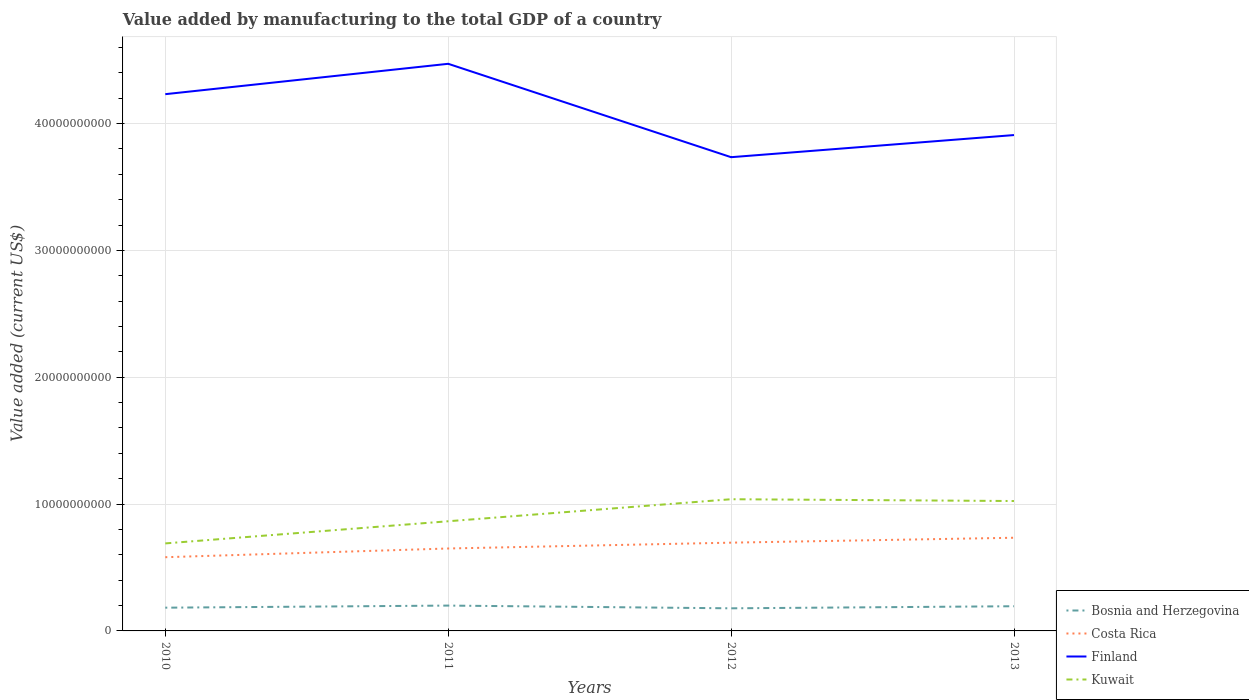How many different coloured lines are there?
Ensure brevity in your answer.  4. Across all years, what is the maximum value added by manufacturing to the total GDP in Kuwait?
Offer a terse response. 6.90e+09. In which year was the value added by manufacturing to the total GDP in Finland maximum?
Keep it short and to the point. 2012. What is the total value added by manufacturing to the total GDP in Kuwait in the graph?
Your answer should be very brief. -3.48e+09. What is the difference between the highest and the second highest value added by manufacturing to the total GDP in Kuwait?
Your response must be concise. 3.48e+09. How many lines are there?
Keep it short and to the point. 4. What is the difference between two consecutive major ticks on the Y-axis?
Your answer should be very brief. 1.00e+1. Does the graph contain any zero values?
Your response must be concise. No. Does the graph contain grids?
Make the answer very short. Yes. Where does the legend appear in the graph?
Provide a succinct answer. Bottom right. How are the legend labels stacked?
Your answer should be very brief. Vertical. What is the title of the graph?
Keep it short and to the point. Value added by manufacturing to the total GDP of a country. Does "Middle East & North Africa (developing only)" appear as one of the legend labels in the graph?
Offer a very short reply. No. What is the label or title of the Y-axis?
Make the answer very short. Value added (current US$). What is the Value added (current US$) of Bosnia and Herzegovina in 2010?
Give a very brief answer. 1.83e+09. What is the Value added (current US$) of Costa Rica in 2010?
Your answer should be very brief. 5.81e+09. What is the Value added (current US$) in Finland in 2010?
Provide a short and direct response. 4.23e+1. What is the Value added (current US$) of Kuwait in 2010?
Offer a terse response. 6.90e+09. What is the Value added (current US$) in Bosnia and Herzegovina in 2011?
Keep it short and to the point. 2.00e+09. What is the Value added (current US$) of Costa Rica in 2011?
Ensure brevity in your answer.  6.50e+09. What is the Value added (current US$) of Finland in 2011?
Make the answer very short. 4.47e+1. What is the Value added (current US$) of Kuwait in 2011?
Give a very brief answer. 8.65e+09. What is the Value added (current US$) in Bosnia and Herzegovina in 2012?
Offer a very short reply. 1.78e+09. What is the Value added (current US$) of Costa Rica in 2012?
Ensure brevity in your answer.  6.96e+09. What is the Value added (current US$) of Finland in 2012?
Provide a succinct answer. 3.73e+1. What is the Value added (current US$) in Kuwait in 2012?
Your answer should be very brief. 1.04e+1. What is the Value added (current US$) of Bosnia and Herzegovina in 2013?
Provide a succinct answer. 1.95e+09. What is the Value added (current US$) of Costa Rica in 2013?
Offer a terse response. 7.35e+09. What is the Value added (current US$) of Finland in 2013?
Give a very brief answer. 3.91e+1. What is the Value added (current US$) in Kuwait in 2013?
Provide a short and direct response. 1.02e+1. Across all years, what is the maximum Value added (current US$) of Bosnia and Herzegovina?
Your answer should be very brief. 2.00e+09. Across all years, what is the maximum Value added (current US$) of Costa Rica?
Keep it short and to the point. 7.35e+09. Across all years, what is the maximum Value added (current US$) in Finland?
Keep it short and to the point. 4.47e+1. Across all years, what is the maximum Value added (current US$) in Kuwait?
Provide a succinct answer. 1.04e+1. Across all years, what is the minimum Value added (current US$) in Bosnia and Herzegovina?
Ensure brevity in your answer.  1.78e+09. Across all years, what is the minimum Value added (current US$) in Costa Rica?
Your answer should be compact. 5.81e+09. Across all years, what is the minimum Value added (current US$) in Finland?
Your answer should be very brief. 3.73e+1. Across all years, what is the minimum Value added (current US$) of Kuwait?
Your answer should be very brief. 6.90e+09. What is the total Value added (current US$) of Bosnia and Herzegovina in the graph?
Ensure brevity in your answer.  7.56e+09. What is the total Value added (current US$) of Costa Rica in the graph?
Your answer should be compact. 2.66e+1. What is the total Value added (current US$) of Finland in the graph?
Provide a succinct answer. 1.63e+11. What is the total Value added (current US$) of Kuwait in the graph?
Give a very brief answer. 3.62e+1. What is the difference between the Value added (current US$) in Bosnia and Herzegovina in 2010 and that in 2011?
Keep it short and to the point. -1.65e+08. What is the difference between the Value added (current US$) in Costa Rica in 2010 and that in 2011?
Your response must be concise. -6.87e+08. What is the difference between the Value added (current US$) of Finland in 2010 and that in 2011?
Your response must be concise. -2.39e+09. What is the difference between the Value added (current US$) of Kuwait in 2010 and that in 2011?
Make the answer very short. -1.75e+09. What is the difference between the Value added (current US$) in Bosnia and Herzegovina in 2010 and that in 2012?
Offer a terse response. 5.01e+07. What is the difference between the Value added (current US$) in Costa Rica in 2010 and that in 2012?
Your response must be concise. -1.15e+09. What is the difference between the Value added (current US$) in Finland in 2010 and that in 2012?
Keep it short and to the point. 4.97e+09. What is the difference between the Value added (current US$) in Kuwait in 2010 and that in 2012?
Make the answer very short. -3.48e+09. What is the difference between the Value added (current US$) in Bosnia and Herzegovina in 2010 and that in 2013?
Offer a very short reply. -1.14e+08. What is the difference between the Value added (current US$) of Costa Rica in 2010 and that in 2013?
Offer a terse response. -1.53e+09. What is the difference between the Value added (current US$) of Finland in 2010 and that in 2013?
Offer a terse response. 3.22e+09. What is the difference between the Value added (current US$) of Kuwait in 2010 and that in 2013?
Provide a succinct answer. -3.34e+09. What is the difference between the Value added (current US$) in Bosnia and Herzegovina in 2011 and that in 2012?
Offer a very short reply. 2.15e+08. What is the difference between the Value added (current US$) of Costa Rica in 2011 and that in 2012?
Offer a very short reply. -4.60e+08. What is the difference between the Value added (current US$) of Finland in 2011 and that in 2012?
Offer a terse response. 7.36e+09. What is the difference between the Value added (current US$) of Kuwait in 2011 and that in 2012?
Provide a short and direct response. -1.74e+09. What is the difference between the Value added (current US$) in Bosnia and Herzegovina in 2011 and that in 2013?
Give a very brief answer. 5.10e+07. What is the difference between the Value added (current US$) of Costa Rica in 2011 and that in 2013?
Your response must be concise. -8.47e+08. What is the difference between the Value added (current US$) of Finland in 2011 and that in 2013?
Keep it short and to the point. 5.62e+09. What is the difference between the Value added (current US$) in Kuwait in 2011 and that in 2013?
Provide a short and direct response. -1.59e+09. What is the difference between the Value added (current US$) of Bosnia and Herzegovina in 2012 and that in 2013?
Keep it short and to the point. -1.64e+08. What is the difference between the Value added (current US$) of Costa Rica in 2012 and that in 2013?
Keep it short and to the point. -3.87e+08. What is the difference between the Value added (current US$) of Finland in 2012 and that in 2013?
Provide a succinct answer. -1.74e+09. What is the difference between the Value added (current US$) of Kuwait in 2012 and that in 2013?
Give a very brief answer. 1.42e+08. What is the difference between the Value added (current US$) in Bosnia and Herzegovina in 2010 and the Value added (current US$) in Costa Rica in 2011?
Keep it short and to the point. -4.67e+09. What is the difference between the Value added (current US$) of Bosnia and Herzegovina in 2010 and the Value added (current US$) of Finland in 2011?
Your answer should be very brief. -4.29e+1. What is the difference between the Value added (current US$) of Bosnia and Herzegovina in 2010 and the Value added (current US$) of Kuwait in 2011?
Offer a terse response. -6.81e+09. What is the difference between the Value added (current US$) in Costa Rica in 2010 and the Value added (current US$) in Finland in 2011?
Keep it short and to the point. -3.89e+1. What is the difference between the Value added (current US$) in Costa Rica in 2010 and the Value added (current US$) in Kuwait in 2011?
Offer a very short reply. -2.83e+09. What is the difference between the Value added (current US$) of Finland in 2010 and the Value added (current US$) of Kuwait in 2011?
Offer a very short reply. 3.37e+1. What is the difference between the Value added (current US$) of Bosnia and Herzegovina in 2010 and the Value added (current US$) of Costa Rica in 2012?
Keep it short and to the point. -5.13e+09. What is the difference between the Value added (current US$) of Bosnia and Herzegovina in 2010 and the Value added (current US$) of Finland in 2012?
Make the answer very short. -3.55e+1. What is the difference between the Value added (current US$) in Bosnia and Herzegovina in 2010 and the Value added (current US$) in Kuwait in 2012?
Ensure brevity in your answer.  -8.55e+09. What is the difference between the Value added (current US$) of Costa Rica in 2010 and the Value added (current US$) of Finland in 2012?
Offer a terse response. -3.15e+1. What is the difference between the Value added (current US$) in Costa Rica in 2010 and the Value added (current US$) in Kuwait in 2012?
Your response must be concise. -4.57e+09. What is the difference between the Value added (current US$) of Finland in 2010 and the Value added (current US$) of Kuwait in 2012?
Your response must be concise. 3.19e+1. What is the difference between the Value added (current US$) of Bosnia and Herzegovina in 2010 and the Value added (current US$) of Costa Rica in 2013?
Give a very brief answer. -5.51e+09. What is the difference between the Value added (current US$) of Bosnia and Herzegovina in 2010 and the Value added (current US$) of Finland in 2013?
Your answer should be compact. -3.73e+1. What is the difference between the Value added (current US$) of Bosnia and Herzegovina in 2010 and the Value added (current US$) of Kuwait in 2013?
Provide a short and direct response. -8.41e+09. What is the difference between the Value added (current US$) of Costa Rica in 2010 and the Value added (current US$) of Finland in 2013?
Your answer should be very brief. -3.33e+1. What is the difference between the Value added (current US$) of Costa Rica in 2010 and the Value added (current US$) of Kuwait in 2013?
Offer a very short reply. -4.43e+09. What is the difference between the Value added (current US$) of Finland in 2010 and the Value added (current US$) of Kuwait in 2013?
Make the answer very short. 3.21e+1. What is the difference between the Value added (current US$) in Bosnia and Herzegovina in 2011 and the Value added (current US$) in Costa Rica in 2012?
Ensure brevity in your answer.  -4.96e+09. What is the difference between the Value added (current US$) of Bosnia and Herzegovina in 2011 and the Value added (current US$) of Finland in 2012?
Give a very brief answer. -3.53e+1. What is the difference between the Value added (current US$) of Bosnia and Herzegovina in 2011 and the Value added (current US$) of Kuwait in 2012?
Offer a very short reply. -8.38e+09. What is the difference between the Value added (current US$) of Costa Rica in 2011 and the Value added (current US$) of Finland in 2012?
Offer a very short reply. -3.08e+1. What is the difference between the Value added (current US$) in Costa Rica in 2011 and the Value added (current US$) in Kuwait in 2012?
Offer a terse response. -3.88e+09. What is the difference between the Value added (current US$) in Finland in 2011 and the Value added (current US$) in Kuwait in 2012?
Provide a succinct answer. 3.43e+1. What is the difference between the Value added (current US$) of Bosnia and Herzegovina in 2011 and the Value added (current US$) of Costa Rica in 2013?
Make the answer very short. -5.35e+09. What is the difference between the Value added (current US$) in Bosnia and Herzegovina in 2011 and the Value added (current US$) in Finland in 2013?
Provide a short and direct response. -3.71e+1. What is the difference between the Value added (current US$) of Bosnia and Herzegovina in 2011 and the Value added (current US$) of Kuwait in 2013?
Keep it short and to the point. -8.24e+09. What is the difference between the Value added (current US$) in Costa Rica in 2011 and the Value added (current US$) in Finland in 2013?
Provide a short and direct response. -3.26e+1. What is the difference between the Value added (current US$) in Costa Rica in 2011 and the Value added (current US$) in Kuwait in 2013?
Make the answer very short. -3.74e+09. What is the difference between the Value added (current US$) of Finland in 2011 and the Value added (current US$) of Kuwait in 2013?
Your answer should be compact. 3.45e+1. What is the difference between the Value added (current US$) in Bosnia and Herzegovina in 2012 and the Value added (current US$) in Costa Rica in 2013?
Offer a very short reply. -5.56e+09. What is the difference between the Value added (current US$) of Bosnia and Herzegovina in 2012 and the Value added (current US$) of Finland in 2013?
Your answer should be very brief. -3.73e+1. What is the difference between the Value added (current US$) in Bosnia and Herzegovina in 2012 and the Value added (current US$) in Kuwait in 2013?
Your answer should be very brief. -8.46e+09. What is the difference between the Value added (current US$) in Costa Rica in 2012 and the Value added (current US$) in Finland in 2013?
Provide a succinct answer. -3.21e+1. What is the difference between the Value added (current US$) in Costa Rica in 2012 and the Value added (current US$) in Kuwait in 2013?
Give a very brief answer. -3.28e+09. What is the difference between the Value added (current US$) of Finland in 2012 and the Value added (current US$) of Kuwait in 2013?
Ensure brevity in your answer.  2.71e+1. What is the average Value added (current US$) in Bosnia and Herzegovina per year?
Make the answer very short. 1.89e+09. What is the average Value added (current US$) in Costa Rica per year?
Your response must be concise. 6.65e+09. What is the average Value added (current US$) of Finland per year?
Ensure brevity in your answer.  4.09e+1. What is the average Value added (current US$) in Kuwait per year?
Keep it short and to the point. 9.04e+09. In the year 2010, what is the difference between the Value added (current US$) in Bosnia and Herzegovina and Value added (current US$) in Costa Rica?
Offer a terse response. -3.98e+09. In the year 2010, what is the difference between the Value added (current US$) in Bosnia and Herzegovina and Value added (current US$) in Finland?
Your response must be concise. -4.05e+1. In the year 2010, what is the difference between the Value added (current US$) in Bosnia and Herzegovina and Value added (current US$) in Kuwait?
Provide a succinct answer. -5.07e+09. In the year 2010, what is the difference between the Value added (current US$) in Costa Rica and Value added (current US$) in Finland?
Offer a terse response. -3.65e+1. In the year 2010, what is the difference between the Value added (current US$) of Costa Rica and Value added (current US$) of Kuwait?
Your response must be concise. -1.09e+09. In the year 2010, what is the difference between the Value added (current US$) in Finland and Value added (current US$) in Kuwait?
Your response must be concise. 3.54e+1. In the year 2011, what is the difference between the Value added (current US$) of Bosnia and Herzegovina and Value added (current US$) of Costa Rica?
Provide a succinct answer. -4.50e+09. In the year 2011, what is the difference between the Value added (current US$) in Bosnia and Herzegovina and Value added (current US$) in Finland?
Make the answer very short. -4.27e+1. In the year 2011, what is the difference between the Value added (current US$) of Bosnia and Herzegovina and Value added (current US$) of Kuwait?
Provide a short and direct response. -6.65e+09. In the year 2011, what is the difference between the Value added (current US$) of Costa Rica and Value added (current US$) of Finland?
Provide a succinct answer. -3.82e+1. In the year 2011, what is the difference between the Value added (current US$) of Costa Rica and Value added (current US$) of Kuwait?
Make the answer very short. -2.15e+09. In the year 2011, what is the difference between the Value added (current US$) of Finland and Value added (current US$) of Kuwait?
Make the answer very short. 3.61e+1. In the year 2012, what is the difference between the Value added (current US$) of Bosnia and Herzegovina and Value added (current US$) of Costa Rica?
Ensure brevity in your answer.  -5.18e+09. In the year 2012, what is the difference between the Value added (current US$) of Bosnia and Herzegovina and Value added (current US$) of Finland?
Your answer should be very brief. -3.56e+1. In the year 2012, what is the difference between the Value added (current US$) of Bosnia and Herzegovina and Value added (current US$) of Kuwait?
Ensure brevity in your answer.  -8.60e+09. In the year 2012, what is the difference between the Value added (current US$) in Costa Rica and Value added (current US$) in Finland?
Keep it short and to the point. -3.04e+1. In the year 2012, what is the difference between the Value added (current US$) in Costa Rica and Value added (current US$) in Kuwait?
Provide a succinct answer. -3.42e+09. In the year 2012, what is the difference between the Value added (current US$) of Finland and Value added (current US$) of Kuwait?
Give a very brief answer. 2.70e+1. In the year 2013, what is the difference between the Value added (current US$) of Bosnia and Herzegovina and Value added (current US$) of Costa Rica?
Your response must be concise. -5.40e+09. In the year 2013, what is the difference between the Value added (current US$) of Bosnia and Herzegovina and Value added (current US$) of Finland?
Make the answer very short. -3.71e+1. In the year 2013, what is the difference between the Value added (current US$) of Bosnia and Herzegovina and Value added (current US$) of Kuwait?
Offer a terse response. -8.29e+09. In the year 2013, what is the difference between the Value added (current US$) of Costa Rica and Value added (current US$) of Finland?
Offer a terse response. -3.17e+1. In the year 2013, what is the difference between the Value added (current US$) of Costa Rica and Value added (current US$) of Kuwait?
Your answer should be very brief. -2.89e+09. In the year 2013, what is the difference between the Value added (current US$) of Finland and Value added (current US$) of Kuwait?
Offer a terse response. 2.89e+1. What is the ratio of the Value added (current US$) in Bosnia and Herzegovina in 2010 to that in 2011?
Make the answer very short. 0.92. What is the ratio of the Value added (current US$) in Costa Rica in 2010 to that in 2011?
Provide a short and direct response. 0.89. What is the ratio of the Value added (current US$) in Finland in 2010 to that in 2011?
Ensure brevity in your answer.  0.95. What is the ratio of the Value added (current US$) in Kuwait in 2010 to that in 2011?
Give a very brief answer. 0.8. What is the ratio of the Value added (current US$) of Bosnia and Herzegovina in 2010 to that in 2012?
Provide a succinct answer. 1.03. What is the ratio of the Value added (current US$) in Costa Rica in 2010 to that in 2012?
Offer a very short reply. 0.84. What is the ratio of the Value added (current US$) of Finland in 2010 to that in 2012?
Provide a short and direct response. 1.13. What is the ratio of the Value added (current US$) of Kuwait in 2010 to that in 2012?
Make the answer very short. 0.66. What is the ratio of the Value added (current US$) of Bosnia and Herzegovina in 2010 to that in 2013?
Your answer should be very brief. 0.94. What is the ratio of the Value added (current US$) of Costa Rica in 2010 to that in 2013?
Your answer should be very brief. 0.79. What is the ratio of the Value added (current US$) in Finland in 2010 to that in 2013?
Give a very brief answer. 1.08. What is the ratio of the Value added (current US$) in Kuwait in 2010 to that in 2013?
Your answer should be compact. 0.67. What is the ratio of the Value added (current US$) of Bosnia and Herzegovina in 2011 to that in 2012?
Ensure brevity in your answer.  1.12. What is the ratio of the Value added (current US$) of Costa Rica in 2011 to that in 2012?
Your answer should be compact. 0.93. What is the ratio of the Value added (current US$) of Finland in 2011 to that in 2012?
Ensure brevity in your answer.  1.2. What is the ratio of the Value added (current US$) of Kuwait in 2011 to that in 2012?
Your answer should be very brief. 0.83. What is the ratio of the Value added (current US$) in Bosnia and Herzegovina in 2011 to that in 2013?
Offer a very short reply. 1.03. What is the ratio of the Value added (current US$) of Costa Rica in 2011 to that in 2013?
Provide a succinct answer. 0.88. What is the ratio of the Value added (current US$) in Finland in 2011 to that in 2013?
Make the answer very short. 1.14. What is the ratio of the Value added (current US$) of Kuwait in 2011 to that in 2013?
Ensure brevity in your answer.  0.84. What is the ratio of the Value added (current US$) of Bosnia and Herzegovina in 2012 to that in 2013?
Provide a succinct answer. 0.92. What is the ratio of the Value added (current US$) in Costa Rica in 2012 to that in 2013?
Give a very brief answer. 0.95. What is the ratio of the Value added (current US$) in Finland in 2012 to that in 2013?
Keep it short and to the point. 0.96. What is the ratio of the Value added (current US$) of Kuwait in 2012 to that in 2013?
Make the answer very short. 1.01. What is the difference between the highest and the second highest Value added (current US$) of Bosnia and Herzegovina?
Give a very brief answer. 5.10e+07. What is the difference between the highest and the second highest Value added (current US$) of Costa Rica?
Ensure brevity in your answer.  3.87e+08. What is the difference between the highest and the second highest Value added (current US$) in Finland?
Provide a short and direct response. 2.39e+09. What is the difference between the highest and the second highest Value added (current US$) of Kuwait?
Make the answer very short. 1.42e+08. What is the difference between the highest and the lowest Value added (current US$) of Bosnia and Herzegovina?
Your answer should be compact. 2.15e+08. What is the difference between the highest and the lowest Value added (current US$) of Costa Rica?
Keep it short and to the point. 1.53e+09. What is the difference between the highest and the lowest Value added (current US$) of Finland?
Provide a short and direct response. 7.36e+09. What is the difference between the highest and the lowest Value added (current US$) in Kuwait?
Make the answer very short. 3.48e+09. 